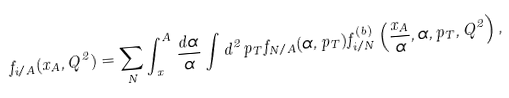Convert formula to latex. <formula><loc_0><loc_0><loc_500><loc_500>f _ { i / A } ( x _ { A } , Q ^ { 2 } ) = \sum _ { N } \int _ { x } ^ { A } \frac { d \alpha } { \alpha } \int d ^ { 2 } p _ { T } f _ { N / A } ( \alpha , p _ { T } ) f ^ { ( b ) } _ { i / N } \left ( \frac { x _ { A } } { \alpha } , \alpha , p _ { T } , Q ^ { 2 } \right ) ,</formula> 